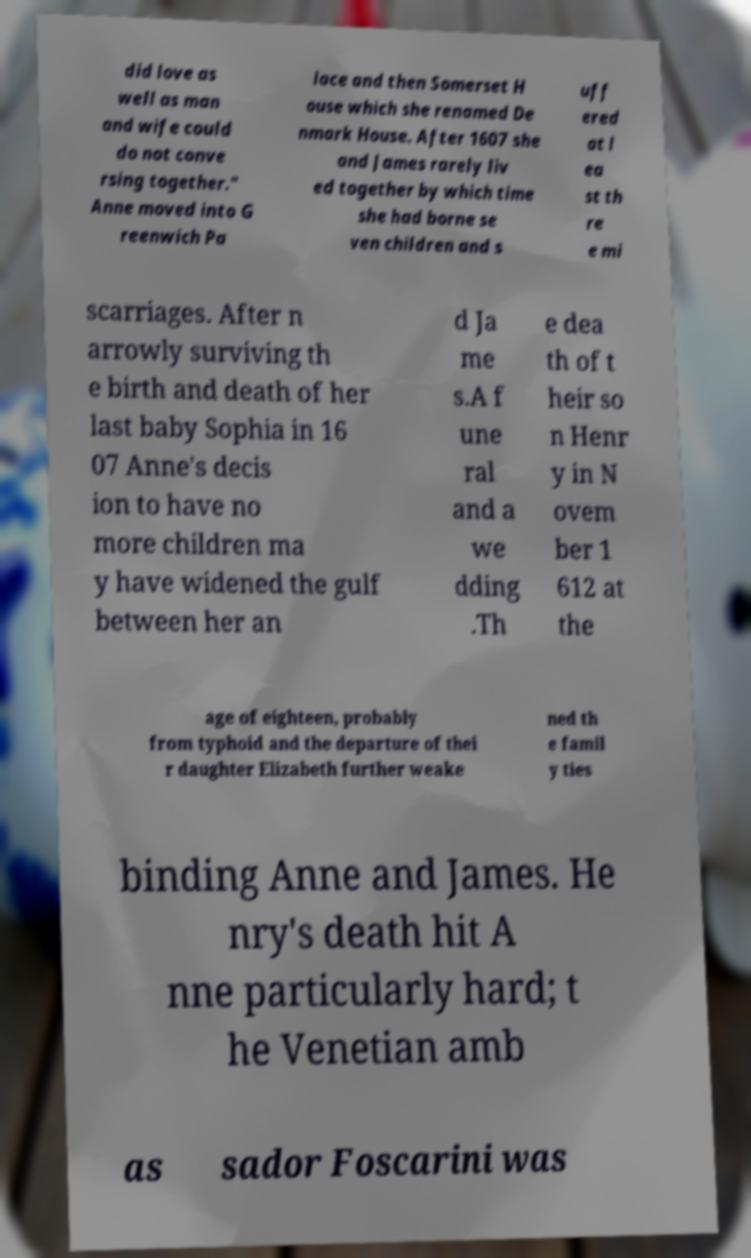Please identify and transcribe the text found in this image. did love as well as man and wife could do not conve rsing together." Anne moved into G reenwich Pa lace and then Somerset H ouse which she renamed De nmark House. After 1607 she and James rarely liv ed together by which time she had borne se ven children and s uff ered at l ea st th re e mi scarriages. After n arrowly surviving th e birth and death of her last baby Sophia in 16 07 Anne's decis ion to have no more children ma y have widened the gulf between her an d Ja me s.A f une ral and a we dding .Th e dea th of t heir so n Henr y in N ovem ber 1 612 at the age of eighteen, probably from typhoid and the departure of thei r daughter Elizabeth further weake ned th e famil y ties binding Anne and James. He nry's death hit A nne particularly hard; t he Venetian amb as sador Foscarini was 